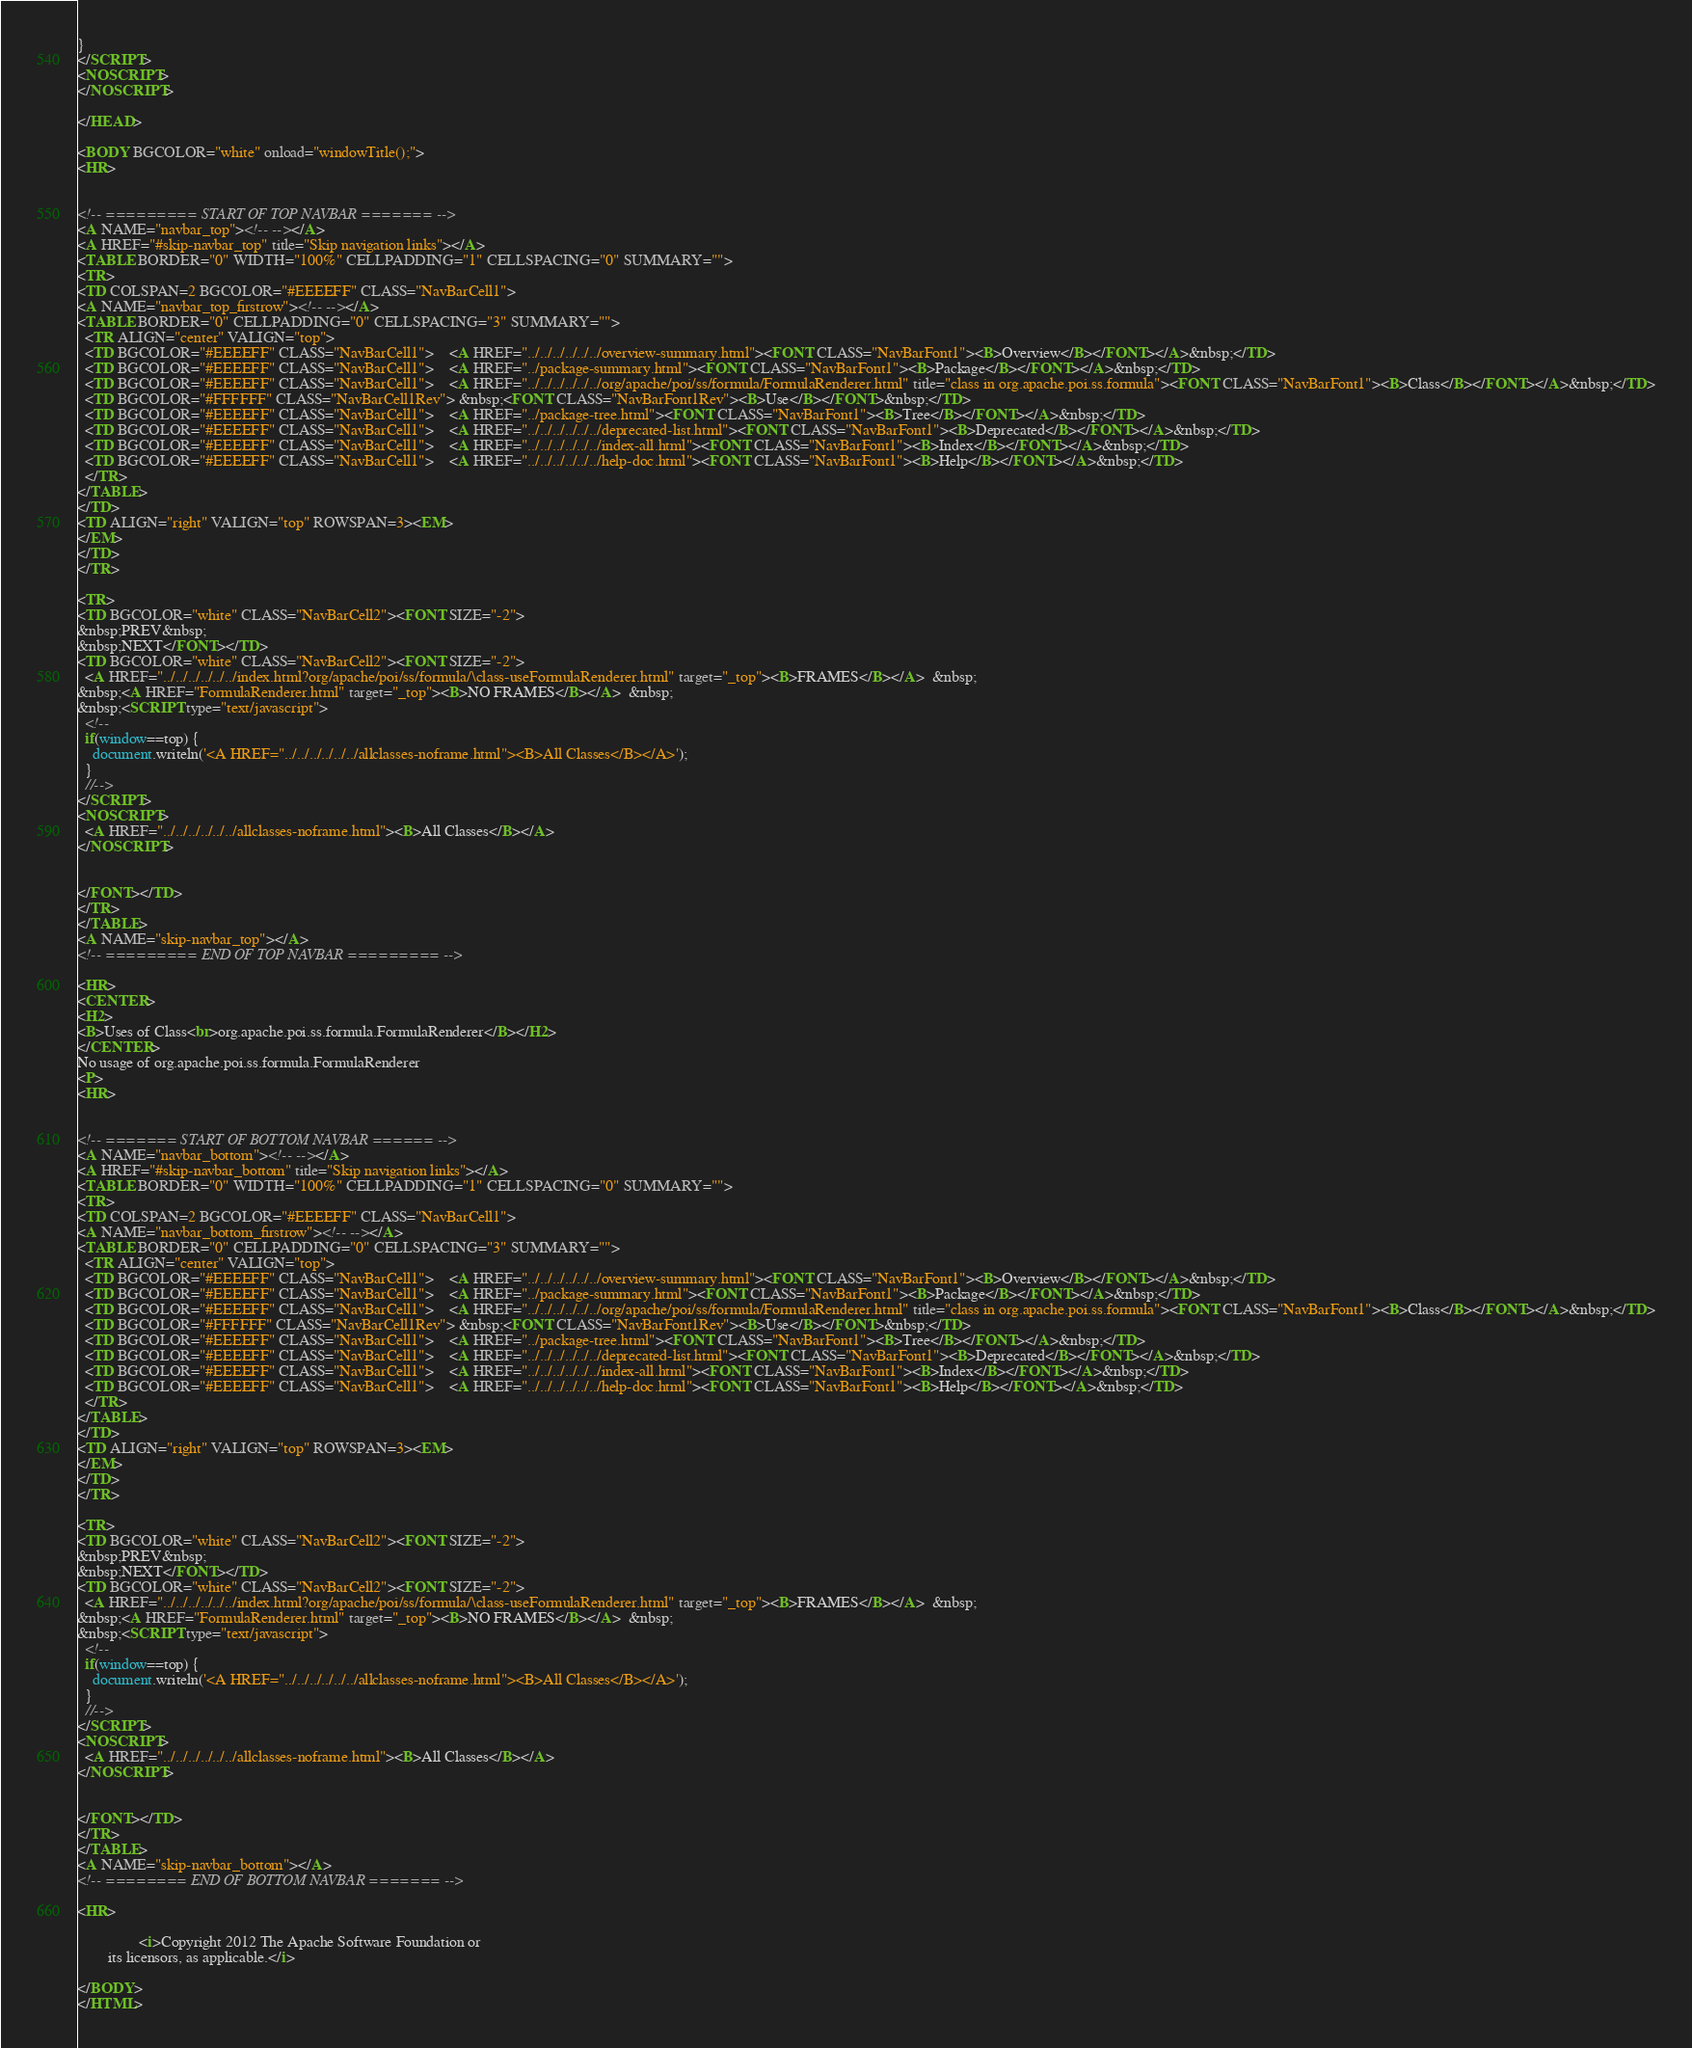Convert code to text. <code><loc_0><loc_0><loc_500><loc_500><_HTML_>}
</SCRIPT>
<NOSCRIPT>
</NOSCRIPT>

</HEAD>

<BODY BGCOLOR="white" onload="windowTitle();">
<HR>


<!-- ========= START OF TOP NAVBAR ======= -->
<A NAME="navbar_top"><!-- --></A>
<A HREF="#skip-navbar_top" title="Skip navigation links"></A>
<TABLE BORDER="0" WIDTH="100%" CELLPADDING="1" CELLSPACING="0" SUMMARY="">
<TR>
<TD COLSPAN=2 BGCOLOR="#EEEEFF" CLASS="NavBarCell1">
<A NAME="navbar_top_firstrow"><!-- --></A>
<TABLE BORDER="0" CELLPADDING="0" CELLSPACING="3" SUMMARY="">
  <TR ALIGN="center" VALIGN="top">
  <TD BGCOLOR="#EEEEFF" CLASS="NavBarCell1">    <A HREF="../../../../../../overview-summary.html"><FONT CLASS="NavBarFont1"><B>Overview</B></FONT></A>&nbsp;</TD>
  <TD BGCOLOR="#EEEEFF" CLASS="NavBarCell1">    <A HREF="../package-summary.html"><FONT CLASS="NavBarFont1"><B>Package</B></FONT></A>&nbsp;</TD>
  <TD BGCOLOR="#EEEEFF" CLASS="NavBarCell1">    <A HREF="../../../../../../org/apache/poi/ss/formula/FormulaRenderer.html" title="class in org.apache.poi.ss.formula"><FONT CLASS="NavBarFont1"><B>Class</B></FONT></A>&nbsp;</TD>
  <TD BGCOLOR="#FFFFFF" CLASS="NavBarCell1Rev"> &nbsp;<FONT CLASS="NavBarFont1Rev"><B>Use</B></FONT>&nbsp;</TD>
  <TD BGCOLOR="#EEEEFF" CLASS="NavBarCell1">    <A HREF="../package-tree.html"><FONT CLASS="NavBarFont1"><B>Tree</B></FONT></A>&nbsp;</TD>
  <TD BGCOLOR="#EEEEFF" CLASS="NavBarCell1">    <A HREF="../../../../../../deprecated-list.html"><FONT CLASS="NavBarFont1"><B>Deprecated</B></FONT></A>&nbsp;</TD>
  <TD BGCOLOR="#EEEEFF" CLASS="NavBarCell1">    <A HREF="../../../../../../index-all.html"><FONT CLASS="NavBarFont1"><B>Index</B></FONT></A>&nbsp;</TD>
  <TD BGCOLOR="#EEEEFF" CLASS="NavBarCell1">    <A HREF="../../../../../../help-doc.html"><FONT CLASS="NavBarFont1"><B>Help</B></FONT></A>&nbsp;</TD>
  </TR>
</TABLE>
</TD>
<TD ALIGN="right" VALIGN="top" ROWSPAN=3><EM>
</EM>
</TD>
</TR>

<TR>
<TD BGCOLOR="white" CLASS="NavBarCell2"><FONT SIZE="-2">
&nbsp;PREV&nbsp;
&nbsp;NEXT</FONT></TD>
<TD BGCOLOR="white" CLASS="NavBarCell2"><FONT SIZE="-2">
  <A HREF="../../../../../../index.html?org/apache/poi/ss/formula/\class-useFormulaRenderer.html" target="_top"><B>FRAMES</B></A>  &nbsp;
&nbsp;<A HREF="FormulaRenderer.html" target="_top"><B>NO FRAMES</B></A>  &nbsp;
&nbsp;<SCRIPT type="text/javascript">
  <!--
  if(window==top) {
    document.writeln('<A HREF="../../../../../../allclasses-noframe.html"><B>All Classes</B></A>');
  }
  //-->
</SCRIPT>
<NOSCRIPT>
  <A HREF="../../../../../../allclasses-noframe.html"><B>All Classes</B></A>
</NOSCRIPT>


</FONT></TD>
</TR>
</TABLE>
<A NAME="skip-navbar_top"></A>
<!-- ========= END OF TOP NAVBAR ========= -->

<HR>
<CENTER>
<H2>
<B>Uses of Class<br>org.apache.poi.ss.formula.FormulaRenderer</B></H2>
</CENTER>
No usage of org.apache.poi.ss.formula.FormulaRenderer
<P>
<HR>


<!-- ======= START OF BOTTOM NAVBAR ====== -->
<A NAME="navbar_bottom"><!-- --></A>
<A HREF="#skip-navbar_bottom" title="Skip navigation links"></A>
<TABLE BORDER="0" WIDTH="100%" CELLPADDING="1" CELLSPACING="0" SUMMARY="">
<TR>
<TD COLSPAN=2 BGCOLOR="#EEEEFF" CLASS="NavBarCell1">
<A NAME="navbar_bottom_firstrow"><!-- --></A>
<TABLE BORDER="0" CELLPADDING="0" CELLSPACING="3" SUMMARY="">
  <TR ALIGN="center" VALIGN="top">
  <TD BGCOLOR="#EEEEFF" CLASS="NavBarCell1">    <A HREF="../../../../../../overview-summary.html"><FONT CLASS="NavBarFont1"><B>Overview</B></FONT></A>&nbsp;</TD>
  <TD BGCOLOR="#EEEEFF" CLASS="NavBarCell1">    <A HREF="../package-summary.html"><FONT CLASS="NavBarFont1"><B>Package</B></FONT></A>&nbsp;</TD>
  <TD BGCOLOR="#EEEEFF" CLASS="NavBarCell1">    <A HREF="../../../../../../org/apache/poi/ss/formula/FormulaRenderer.html" title="class in org.apache.poi.ss.formula"><FONT CLASS="NavBarFont1"><B>Class</B></FONT></A>&nbsp;</TD>
  <TD BGCOLOR="#FFFFFF" CLASS="NavBarCell1Rev"> &nbsp;<FONT CLASS="NavBarFont1Rev"><B>Use</B></FONT>&nbsp;</TD>
  <TD BGCOLOR="#EEEEFF" CLASS="NavBarCell1">    <A HREF="../package-tree.html"><FONT CLASS="NavBarFont1"><B>Tree</B></FONT></A>&nbsp;</TD>
  <TD BGCOLOR="#EEEEFF" CLASS="NavBarCell1">    <A HREF="../../../../../../deprecated-list.html"><FONT CLASS="NavBarFont1"><B>Deprecated</B></FONT></A>&nbsp;</TD>
  <TD BGCOLOR="#EEEEFF" CLASS="NavBarCell1">    <A HREF="../../../../../../index-all.html"><FONT CLASS="NavBarFont1"><B>Index</B></FONT></A>&nbsp;</TD>
  <TD BGCOLOR="#EEEEFF" CLASS="NavBarCell1">    <A HREF="../../../../../../help-doc.html"><FONT CLASS="NavBarFont1"><B>Help</B></FONT></A>&nbsp;</TD>
  </TR>
</TABLE>
</TD>
<TD ALIGN="right" VALIGN="top" ROWSPAN=3><EM>
</EM>
</TD>
</TR>

<TR>
<TD BGCOLOR="white" CLASS="NavBarCell2"><FONT SIZE="-2">
&nbsp;PREV&nbsp;
&nbsp;NEXT</FONT></TD>
<TD BGCOLOR="white" CLASS="NavBarCell2"><FONT SIZE="-2">
  <A HREF="../../../../../../index.html?org/apache/poi/ss/formula/\class-useFormulaRenderer.html" target="_top"><B>FRAMES</B></A>  &nbsp;
&nbsp;<A HREF="FormulaRenderer.html" target="_top"><B>NO FRAMES</B></A>  &nbsp;
&nbsp;<SCRIPT type="text/javascript">
  <!--
  if(window==top) {
    document.writeln('<A HREF="../../../../../../allclasses-noframe.html"><B>All Classes</B></A>');
  }
  //-->
</SCRIPT>
<NOSCRIPT>
  <A HREF="../../../../../../allclasses-noframe.html"><B>All Classes</B></A>
</NOSCRIPT>


</FONT></TD>
</TR>
</TABLE>
<A NAME="skip-navbar_bottom"></A>
<!-- ======== END OF BOTTOM NAVBAR ======= -->

<HR>

                <i>Copyright 2012 The Apache Software Foundation or
        its licensors, as applicable.</i>
            
</BODY>
</HTML>
</code> 